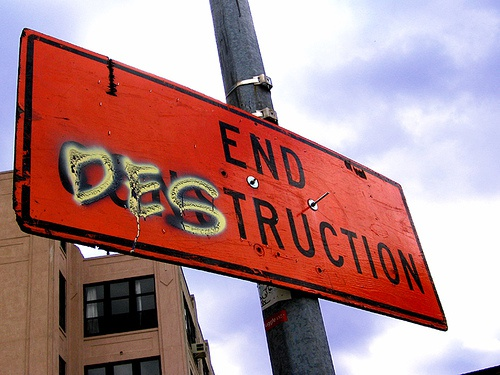Describe the objects in this image and their specific colors. I can see various objects in this image with different colors. 